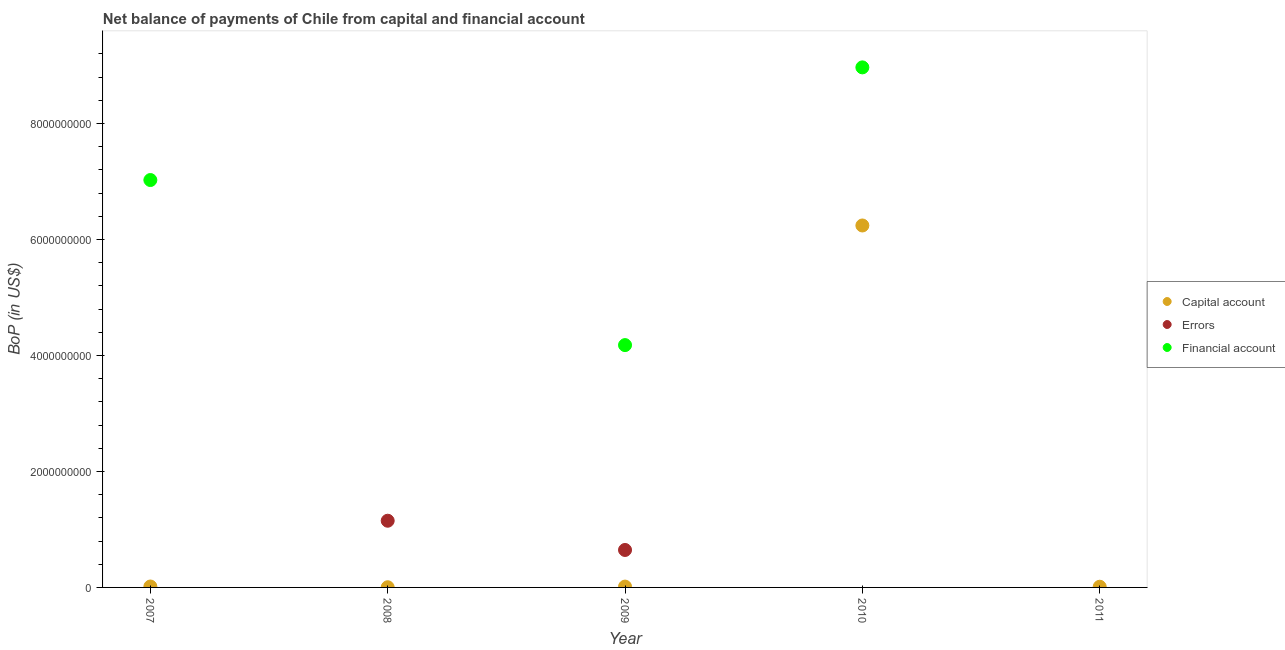How many different coloured dotlines are there?
Your answer should be compact. 3. What is the amount of net capital account in 2007?
Keep it short and to the point. 1.57e+07. Across all years, what is the maximum amount of financial account?
Provide a succinct answer. 8.97e+09. Across all years, what is the minimum amount of errors?
Offer a terse response. 0. What is the total amount of net capital account in the graph?
Offer a very short reply. 6.29e+09. What is the difference between the amount of net capital account in 2008 and that in 2010?
Offer a very short reply. -6.24e+09. What is the average amount of net capital account per year?
Ensure brevity in your answer.  1.26e+09. In the year 2007, what is the difference between the amount of net capital account and amount of financial account?
Provide a short and direct response. -7.01e+09. What is the ratio of the amount of financial account in 2009 to that in 2010?
Provide a short and direct response. 0.47. Is the amount of net capital account in 2010 less than that in 2011?
Offer a terse response. No. What is the difference between the highest and the second highest amount of net capital account?
Ensure brevity in your answer.  6.22e+09. What is the difference between the highest and the lowest amount of errors?
Provide a succinct answer. 1.15e+09. In how many years, is the amount of net capital account greater than the average amount of net capital account taken over all years?
Your answer should be compact. 1. Is the sum of the amount of financial account in 2009 and 2010 greater than the maximum amount of errors across all years?
Provide a short and direct response. Yes. Is it the case that in every year, the sum of the amount of net capital account and amount of errors is greater than the amount of financial account?
Your answer should be very brief. No. Does the amount of net capital account monotonically increase over the years?
Your answer should be very brief. No. Is the amount of financial account strictly less than the amount of net capital account over the years?
Provide a short and direct response. No. Does the graph contain any zero values?
Ensure brevity in your answer.  Yes. Does the graph contain grids?
Make the answer very short. No. Where does the legend appear in the graph?
Provide a succinct answer. Center right. What is the title of the graph?
Provide a short and direct response. Net balance of payments of Chile from capital and financial account. What is the label or title of the X-axis?
Give a very brief answer. Year. What is the label or title of the Y-axis?
Offer a very short reply. BoP (in US$). What is the BoP (in US$) in Capital account in 2007?
Your response must be concise. 1.57e+07. What is the BoP (in US$) in Financial account in 2007?
Offer a very short reply. 7.02e+09. What is the BoP (in US$) in Capital account in 2008?
Offer a terse response. 3.06e+06. What is the BoP (in US$) of Errors in 2008?
Provide a succinct answer. 1.15e+09. What is the BoP (in US$) in Financial account in 2008?
Give a very brief answer. 0. What is the BoP (in US$) of Capital account in 2009?
Offer a very short reply. 1.45e+07. What is the BoP (in US$) of Errors in 2009?
Provide a succinct answer. 6.46e+08. What is the BoP (in US$) of Financial account in 2009?
Keep it short and to the point. 4.18e+09. What is the BoP (in US$) of Capital account in 2010?
Your response must be concise. 6.24e+09. What is the BoP (in US$) in Errors in 2010?
Make the answer very short. 0. What is the BoP (in US$) in Financial account in 2010?
Your answer should be very brief. 8.97e+09. What is the BoP (in US$) of Capital account in 2011?
Provide a succinct answer. 1.19e+07. What is the BoP (in US$) in Errors in 2011?
Make the answer very short. 0. What is the BoP (in US$) of Financial account in 2011?
Ensure brevity in your answer.  0. Across all years, what is the maximum BoP (in US$) in Capital account?
Offer a very short reply. 6.24e+09. Across all years, what is the maximum BoP (in US$) in Errors?
Give a very brief answer. 1.15e+09. Across all years, what is the maximum BoP (in US$) in Financial account?
Your answer should be very brief. 8.97e+09. Across all years, what is the minimum BoP (in US$) in Capital account?
Your response must be concise. 3.06e+06. Across all years, what is the minimum BoP (in US$) of Financial account?
Ensure brevity in your answer.  0. What is the total BoP (in US$) in Capital account in the graph?
Give a very brief answer. 6.29e+09. What is the total BoP (in US$) of Errors in the graph?
Offer a very short reply. 1.80e+09. What is the total BoP (in US$) in Financial account in the graph?
Keep it short and to the point. 2.02e+1. What is the difference between the BoP (in US$) of Capital account in 2007 and that in 2008?
Your response must be concise. 1.27e+07. What is the difference between the BoP (in US$) of Capital account in 2007 and that in 2009?
Make the answer very short. 1.20e+06. What is the difference between the BoP (in US$) of Financial account in 2007 and that in 2009?
Your answer should be compact. 2.85e+09. What is the difference between the BoP (in US$) in Capital account in 2007 and that in 2010?
Your answer should be compact. -6.22e+09. What is the difference between the BoP (in US$) in Financial account in 2007 and that in 2010?
Give a very brief answer. -1.94e+09. What is the difference between the BoP (in US$) of Capital account in 2007 and that in 2011?
Your answer should be very brief. 3.81e+06. What is the difference between the BoP (in US$) in Capital account in 2008 and that in 2009?
Keep it short and to the point. -1.14e+07. What is the difference between the BoP (in US$) in Errors in 2008 and that in 2009?
Provide a succinct answer. 5.04e+08. What is the difference between the BoP (in US$) of Capital account in 2008 and that in 2010?
Offer a very short reply. -6.24e+09. What is the difference between the BoP (in US$) in Capital account in 2008 and that in 2011?
Provide a short and direct response. -8.85e+06. What is the difference between the BoP (in US$) of Capital account in 2009 and that in 2010?
Your answer should be compact. -6.23e+09. What is the difference between the BoP (in US$) of Financial account in 2009 and that in 2010?
Offer a terse response. -4.79e+09. What is the difference between the BoP (in US$) in Capital account in 2009 and that in 2011?
Provide a short and direct response. 2.60e+06. What is the difference between the BoP (in US$) of Capital account in 2010 and that in 2011?
Ensure brevity in your answer.  6.23e+09. What is the difference between the BoP (in US$) in Capital account in 2007 and the BoP (in US$) in Errors in 2008?
Offer a very short reply. -1.13e+09. What is the difference between the BoP (in US$) of Capital account in 2007 and the BoP (in US$) of Errors in 2009?
Your answer should be very brief. -6.30e+08. What is the difference between the BoP (in US$) of Capital account in 2007 and the BoP (in US$) of Financial account in 2009?
Your answer should be compact. -4.16e+09. What is the difference between the BoP (in US$) in Capital account in 2007 and the BoP (in US$) in Financial account in 2010?
Your response must be concise. -8.95e+09. What is the difference between the BoP (in US$) in Capital account in 2008 and the BoP (in US$) in Errors in 2009?
Provide a succinct answer. -6.43e+08. What is the difference between the BoP (in US$) of Capital account in 2008 and the BoP (in US$) of Financial account in 2009?
Provide a succinct answer. -4.18e+09. What is the difference between the BoP (in US$) in Errors in 2008 and the BoP (in US$) in Financial account in 2009?
Offer a terse response. -3.03e+09. What is the difference between the BoP (in US$) of Capital account in 2008 and the BoP (in US$) of Financial account in 2010?
Provide a short and direct response. -8.96e+09. What is the difference between the BoP (in US$) of Errors in 2008 and the BoP (in US$) of Financial account in 2010?
Your response must be concise. -7.82e+09. What is the difference between the BoP (in US$) in Capital account in 2009 and the BoP (in US$) in Financial account in 2010?
Give a very brief answer. -8.95e+09. What is the difference between the BoP (in US$) of Errors in 2009 and the BoP (in US$) of Financial account in 2010?
Give a very brief answer. -8.32e+09. What is the average BoP (in US$) of Capital account per year?
Offer a very short reply. 1.26e+09. What is the average BoP (in US$) of Errors per year?
Provide a short and direct response. 3.59e+08. What is the average BoP (in US$) of Financial account per year?
Offer a very short reply. 4.03e+09. In the year 2007, what is the difference between the BoP (in US$) in Capital account and BoP (in US$) in Financial account?
Offer a very short reply. -7.01e+09. In the year 2008, what is the difference between the BoP (in US$) in Capital account and BoP (in US$) in Errors?
Your answer should be very brief. -1.15e+09. In the year 2009, what is the difference between the BoP (in US$) of Capital account and BoP (in US$) of Errors?
Offer a terse response. -6.31e+08. In the year 2009, what is the difference between the BoP (in US$) in Capital account and BoP (in US$) in Financial account?
Provide a short and direct response. -4.16e+09. In the year 2009, what is the difference between the BoP (in US$) of Errors and BoP (in US$) of Financial account?
Ensure brevity in your answer.  -3.53e+09. In the year 2010, what is the difference between the BoP (in US$) in Capital account and BoP (in US$) in Financial account?
Give a very brief answer. -2.73e+09. What is the ratio of the BoP (in US$) in Capital account in 2007 to that in 2008?
Offer a very short reply. 5.14. What is the ratio of the BoP (in US$) of Capital account in 2007 to that in 2009?
Your answer should be compact. 1.08. What is the ratio of the BoP (in US$) in Financial account in 2007 to that in 2009?
Your answer should be very brief. 1.68. What is the ratio of the BoP (in US$) in Capital account in 2007 to that in 2010?
Keep it short and to the point. 0. What is the ratio of the BoP (in US$) in Financial account in 2007 to that in 2010?
Your answer should be very brief. 0.78. What is the ratio of the BoP (in US$) in Capital account in 2007 to that in 2011?
Keep it short and to the point. 1.32. What is the ratio of the BoP (in US$) of Capital account in 2008 to that in 2009?
Your answer should be compact. 0.21. What is the ratio of the BoP (in US$) of Errors in 2008 to that in 2009?
Your response must be concise. 1.78. What is the ratio of the BoP (in US$) of Capital account in 2008 to that in 2011?
Make the answer very short. 0.26. What is the ratio of the BoP (in US$) of Capital account in 2009 to that in 2010?
Provide a succinct answer. 0. What is the ratio of the BoP (in US$) in Financial account in 2009 to that in 2010?
Offer a very short reply. 0.47. What is the ratio of the BoP (in US$) in Capital account in 2009 to that in 2011?
Your answer should be compact. 1.22. What is the ratio of the BoP (in US$) of Capital account in 2010 to that in 2011?
Offer a terse response. 524.3. What is the difference between the highest and the second highest BoP (in US$) of Capital account?
Your answer should be very brief. 6.22e+09. What is the difference between the highest and the second highest BoP (in US$) in Financial account?
Ensure brevity in your answer.  1.94e+09. What is the difference between the highest and the lowest BoP (in US$) in Capital account?
Your answer should be very brief. 6.24e+09. What is the difference between the highest and the lowest BoP (in US$) in Errors?
Your answer should be very brief. 1.15e+09. What is the difference between the highest and the lowest BoP (in US$) of Financial account?
Provide a short and direct response. 8.97e+09. 